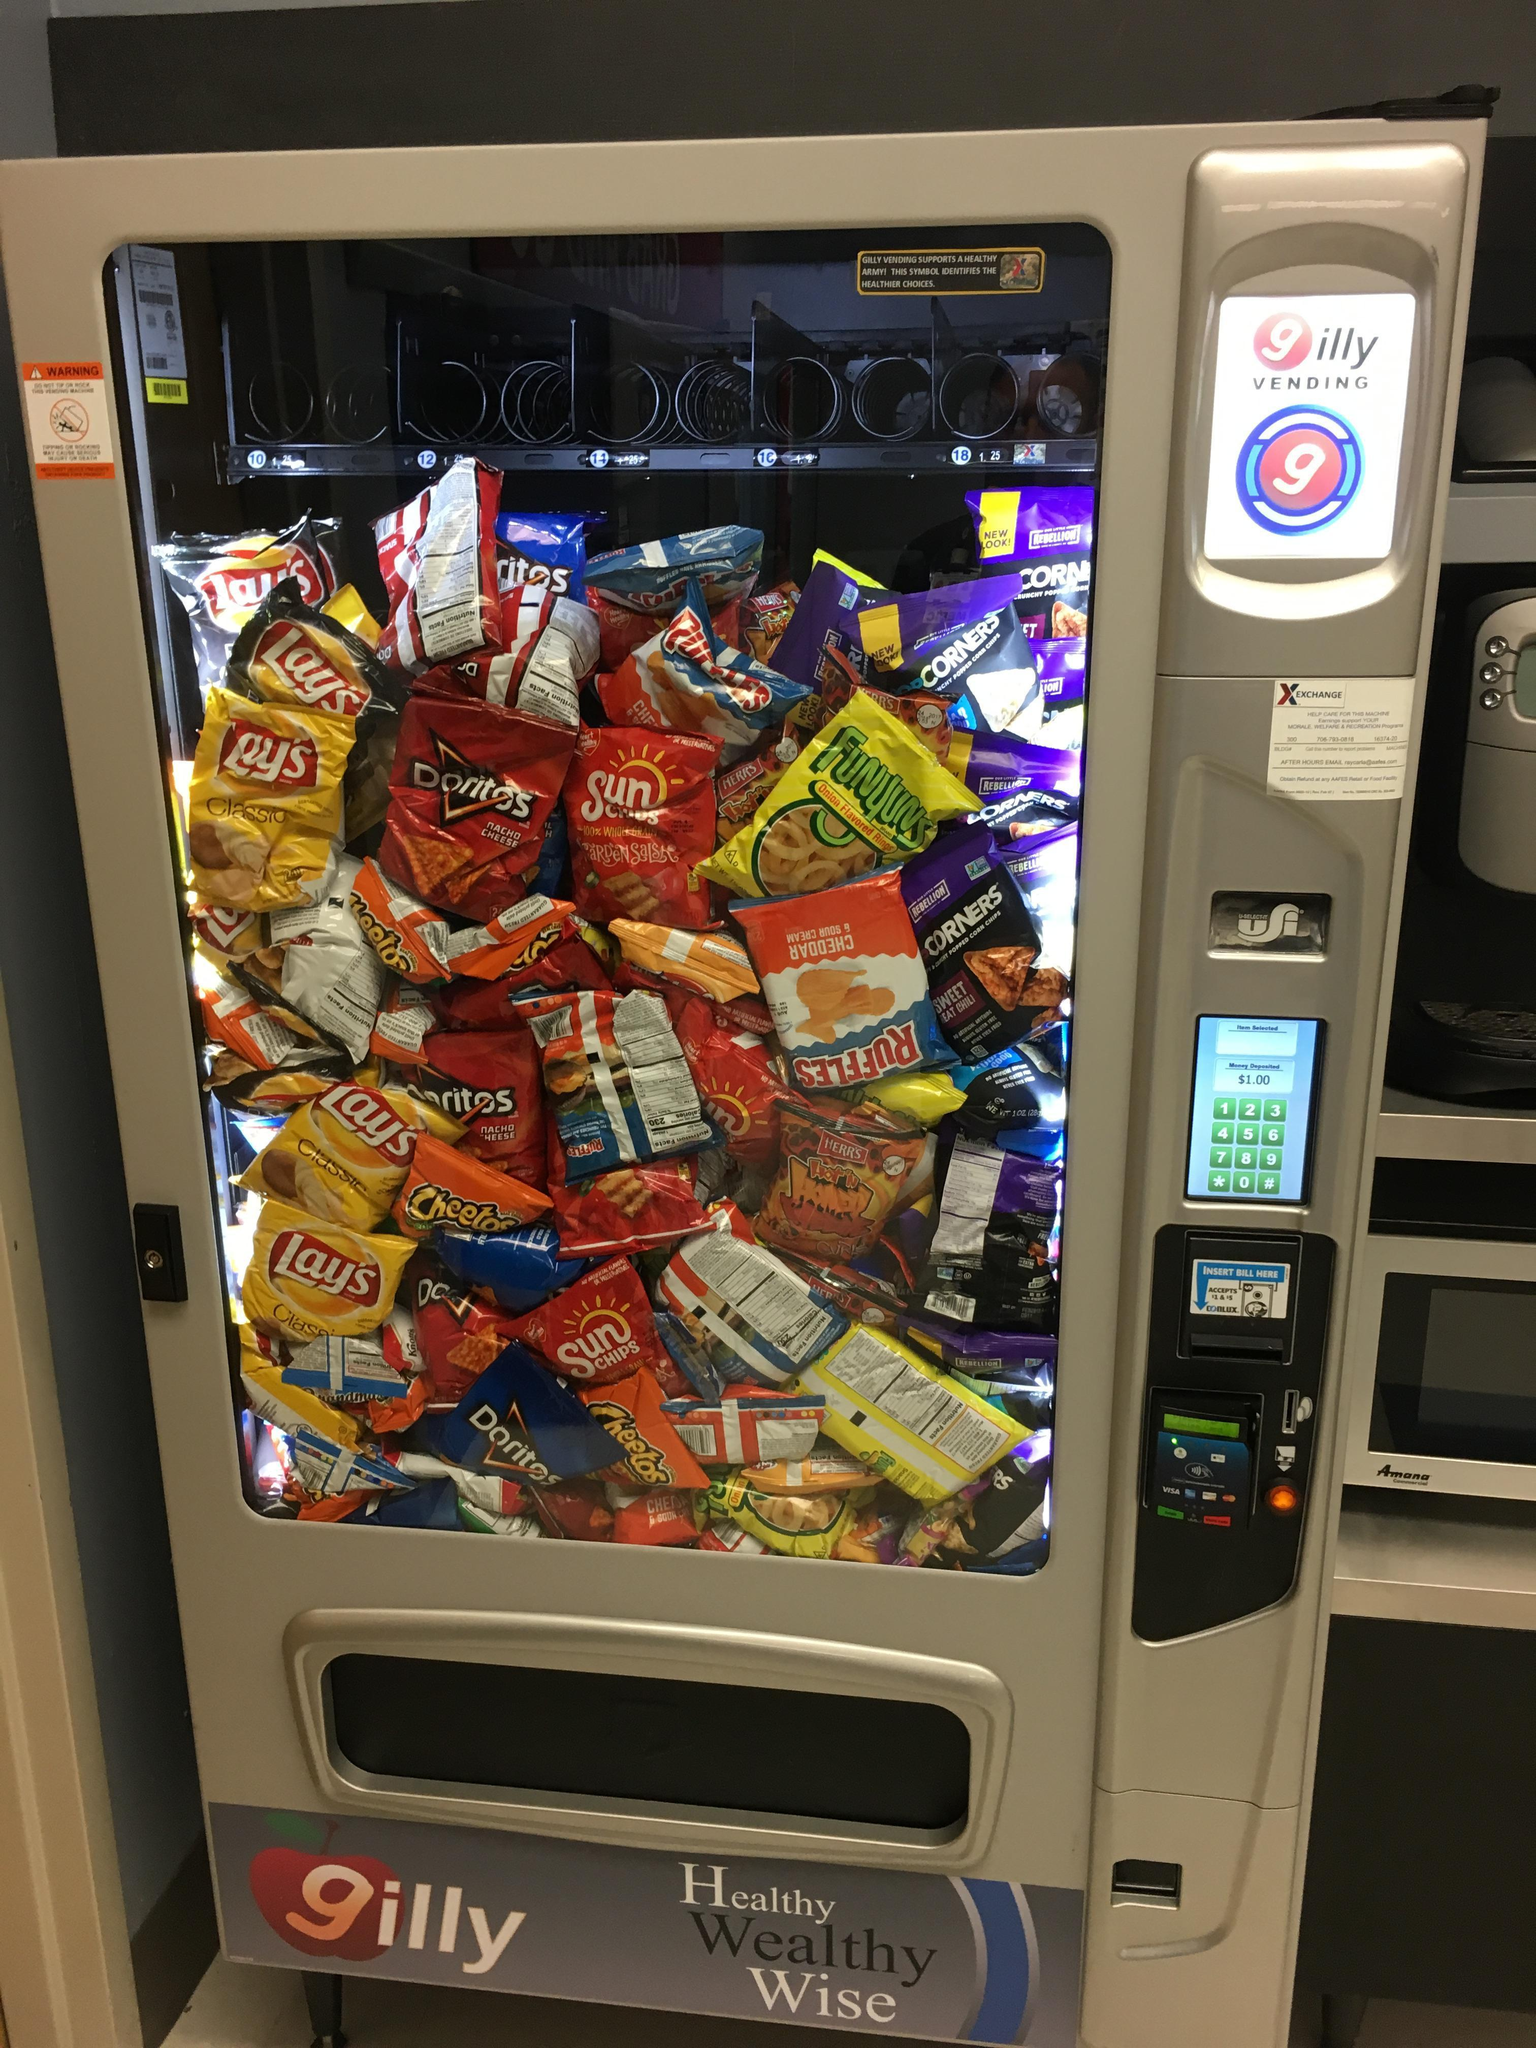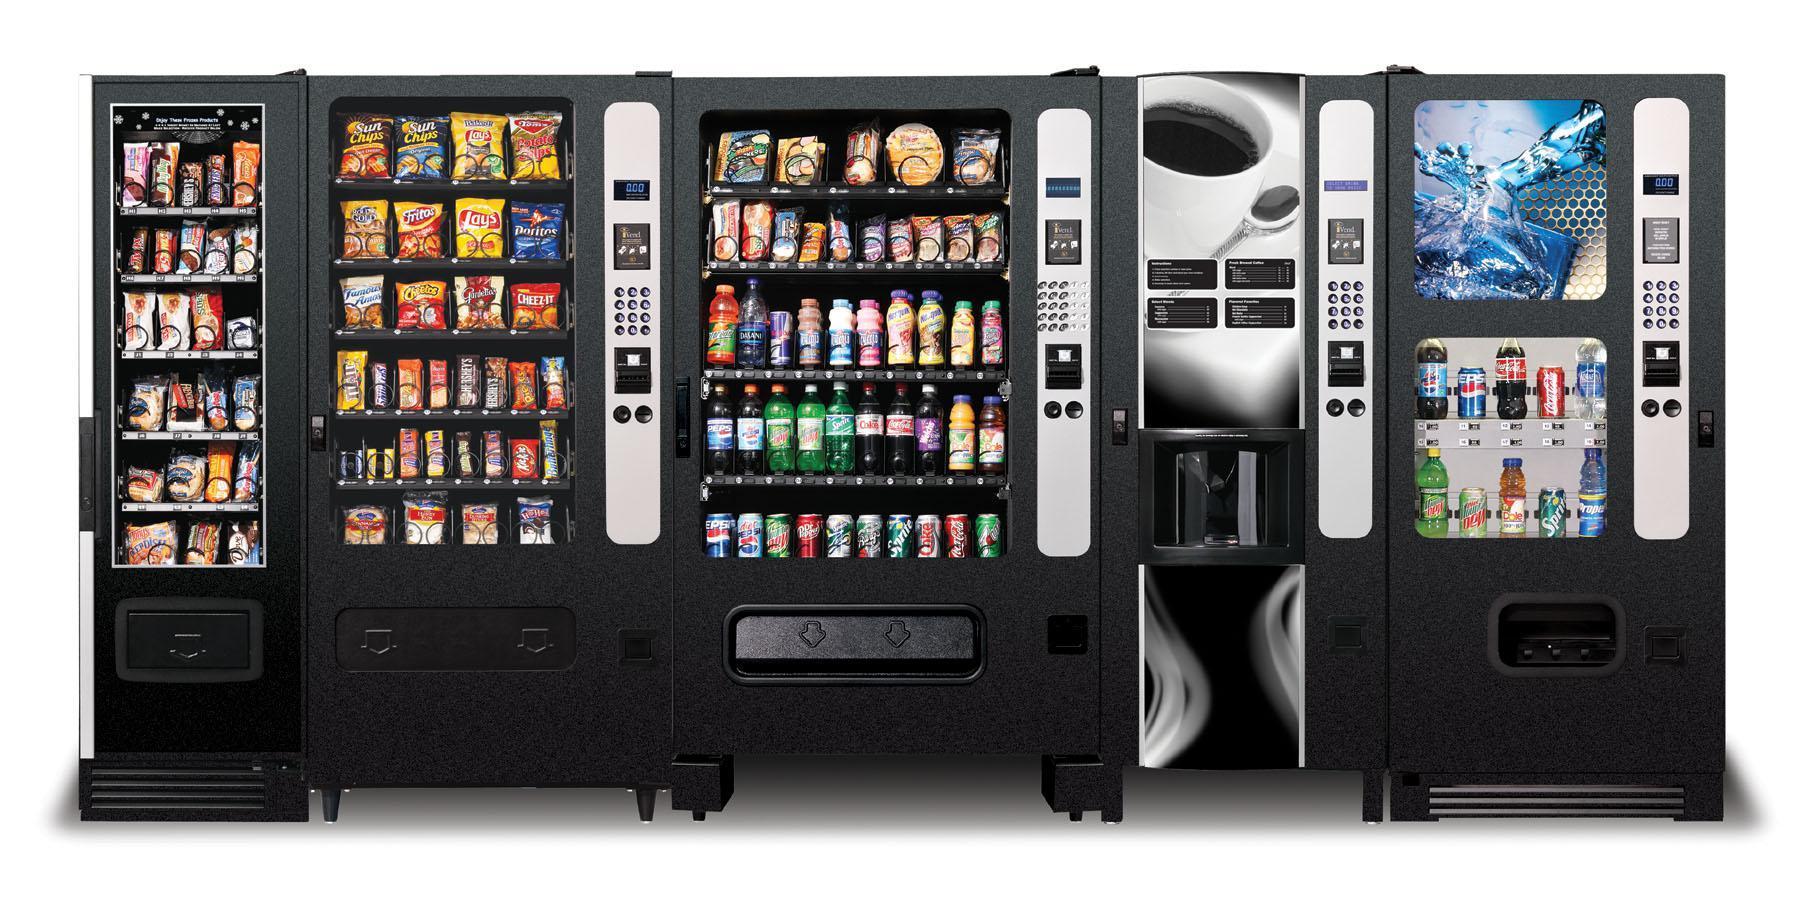The first image is the image on the left, the second image is the image on the right. Examine the images to the left and right. Is the description "At least one vending machine is loaded with drinks." accurate? Answer yes or no. Yes. 